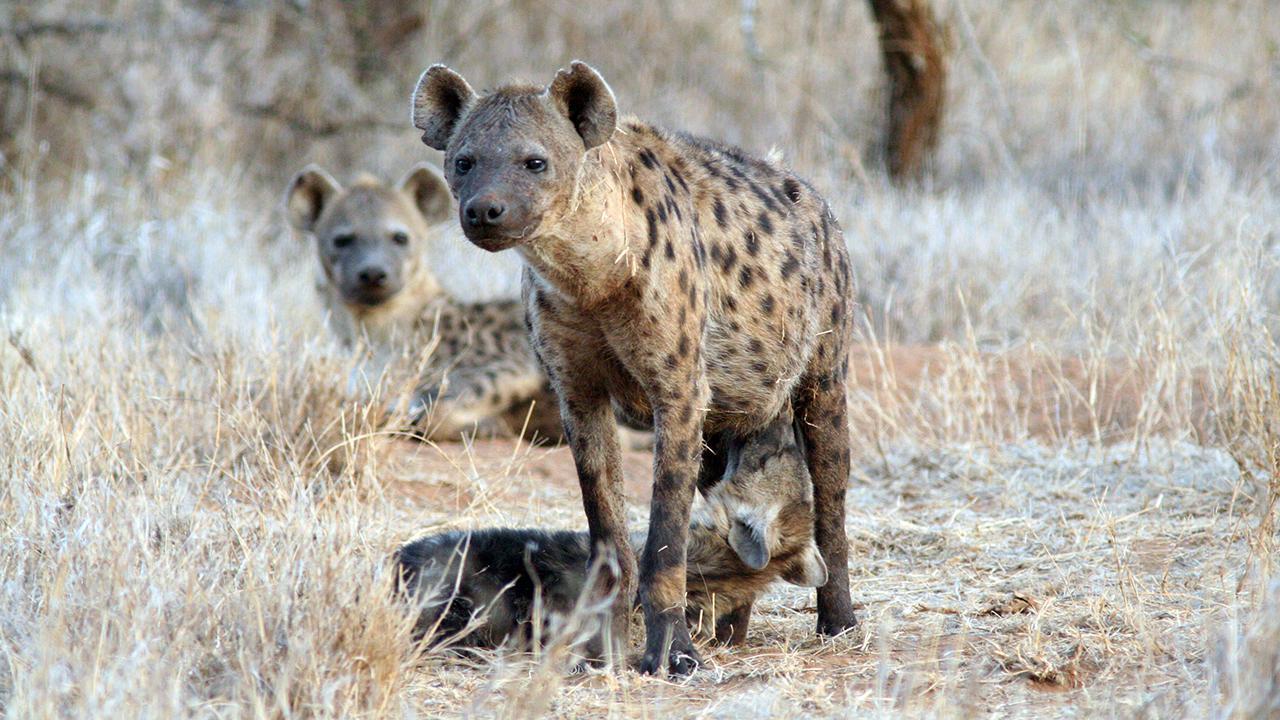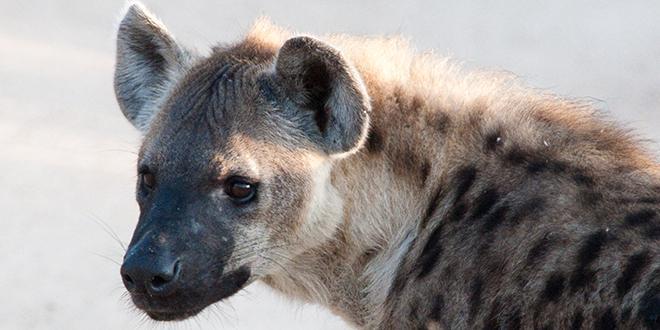The first image is the image on the left, the second image is the image on the right. For the images displayed, is the sentence "The lefthand image includes multiple hyenas, and at least one hyena stands with its nose bent to the ground." factually correct? Answer yes or no. No. The first image is the image on the left, the second image is the image on the right. For the images displayed, is the sentence "There are four hyenas." factually correct? Answer yes or no. Yes. 